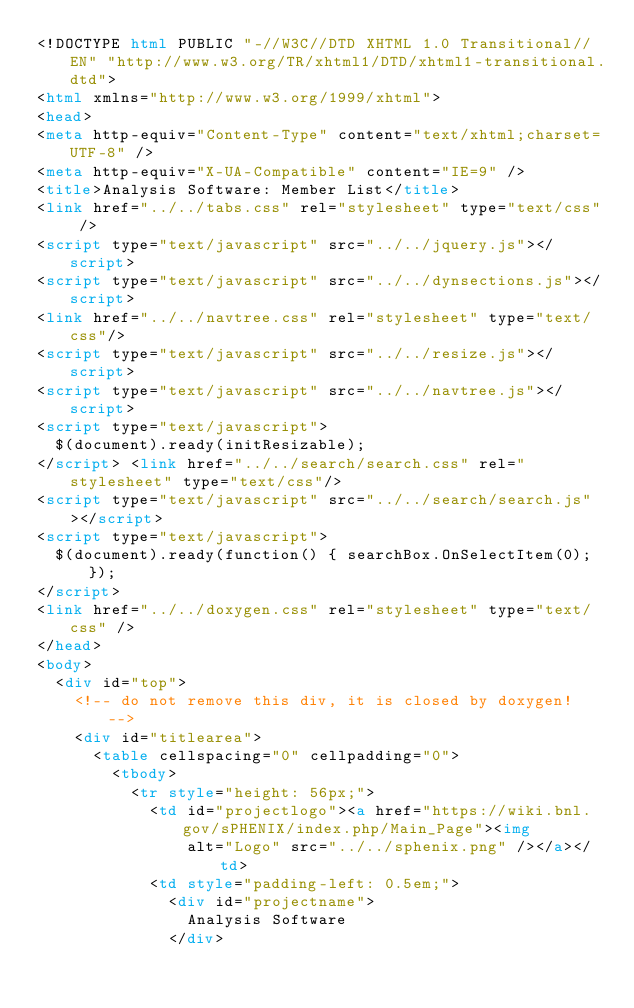Convert code to text. <code><loc_0><loc_0><loc_500><loc_500><_HTML_><!DOCTYPE html PUBLIC "-//W3C//DTD XHTML 1.0 Transitional//EN" "http://www.w3.org/TR/xhtml1/DTD/xhtml1-transitional.dtd">
<html xmlns="http://www.w3.org/1999/xhtml">
<head>
<meta http-equiv="Content-Type" content="text/xhtml;charset=UTF-8" />
<meta http-equiv="X-UA-Compatible" content="IE=9" />
<title>Analysis Software: Member List</title>
<link href="../../tabs.css" rel="stylesheet" type="text/css" />
<script type="text/javascript" src="../../jquery.js"></script>
<script type="text/javascript" src="../../dynsections.js"></script>
<link href="../../navtree.css" rel="stylesheet" type="text/css"/>
<script type="text/javascript" src="../../resize.js"></script>
<script type="text/javascript" src="../../navtree.js"></script>
<script type="text/javascript">
  $(document).ready(initResizable);
</script> <link href="../../search/search.css" rel="stylesheet" type="text/css"/>
<script type="text/javascript" src="../../search/search.js"></script>
<script type="text/javascript">
  $(document).ready(function() { searchBox.OnSelectItem(0); });
</script> 
<link href="../../doxygen.css" rel="stylesheet" type="text/css" />
</head>
<body>
	<div id="top">
		<!-- do not remove this div, it is closed by doxygen! -->
		<div id="titlearea">
			<table cellspacing="0" cellpadding="0">
				<tbody>
					<tr style="height: 56px;">
						<td id="projectlogo"><a href="https://wiki.bnl.gov/sPHENIX/index.php/Main_Page"><img
								alt="Logo" src="../../sphenix.png" /></a></td>
						<td style="padding-left: 0.5em;">
							<div id="projectname">
								Analysis Software
							</div> </code> 